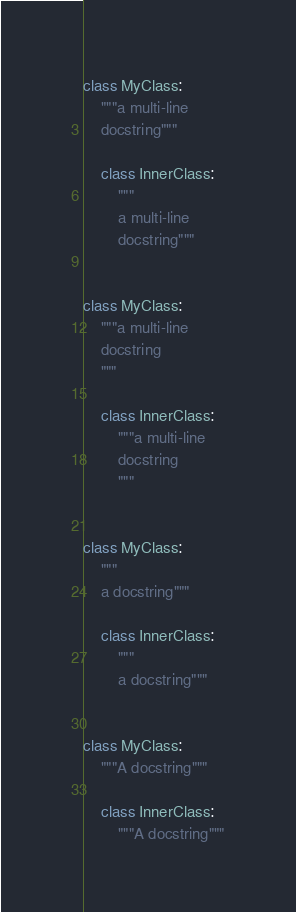Convert code to text. <code><loc_0><loc_0><loc_500><loc_500><_Python_>class MyClass:
    """a multi-line
    docstring"""

    class InnerClass:
        """
        a multi-line
        docstring"""


class MyClass:
    """a multi-line
    docstring
    """

    class InnerClass:
        """a multi-line
        docstring
        """


class MyClass:
    """
    a docstring"""

    class InnerClass:
        """
        a docstring"""


class MyClass:
    """A docstring"""

    class InnerClass:
        """A docstring"""
</code> 